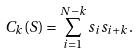Convert formula to latex. <formula><loc_0><loc_0><loc_500><loc_500>C _ { k } ( S ) = \sum _ { i = 1 } ^ { N - k } s _ { i } s _ { i + k } .</formula> 